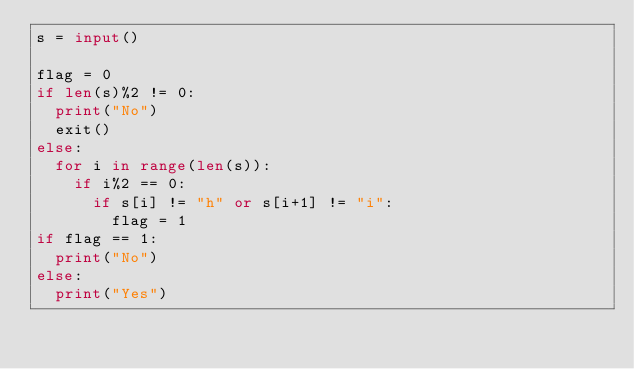Convert code to text. <code><loc_0><loc_0><loc_500><loc_500><_Python_>s = input()

flag = 0
if len(s)%2 != 0:
	print("No")
	exit()
else:
	for i in range(len(s)):
		if i%2 == 0:
			if s[i] != "h" or s[i+1] != "i":
				flag = 1
if flag == 1:
	print("No")
else:
	print("Yes")



</code> 